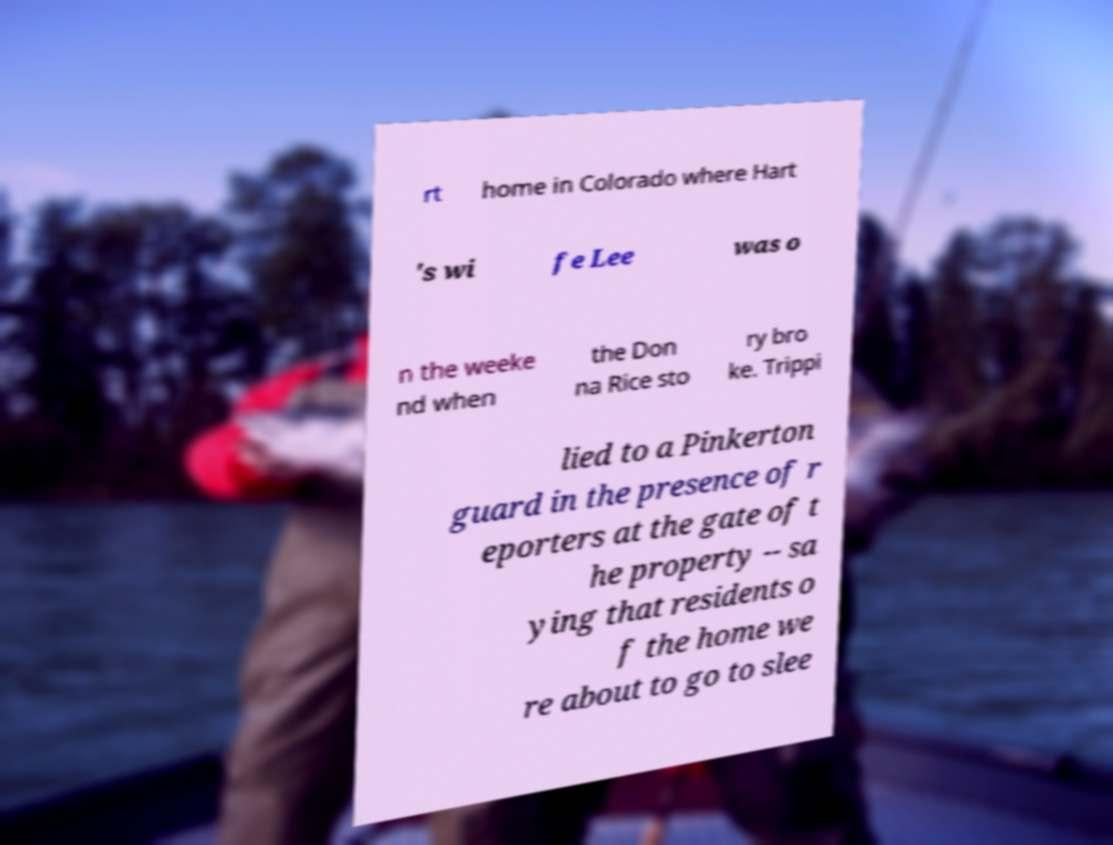For documentation purposes, I need the text within this image transcribed. Could you provide that? rt home in Colorado where Hart 's wi fe Lee was o n the weeke nd when the Don na Rice sto ry bro ke. Trippi lied to a Pinkerton guard in the presence of r eporters at the gate of t he property -- sa ying that residents o f the home we re about to go to slee 